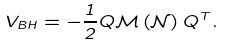<formula> <loc_0><loc_0><loc_500><loc_500>V _ { B H } = - \frac { 1 } { 2 } Q \mathcal { M } \left ( \mathcal { N } \right ) Q ^ { T } .</formula> 